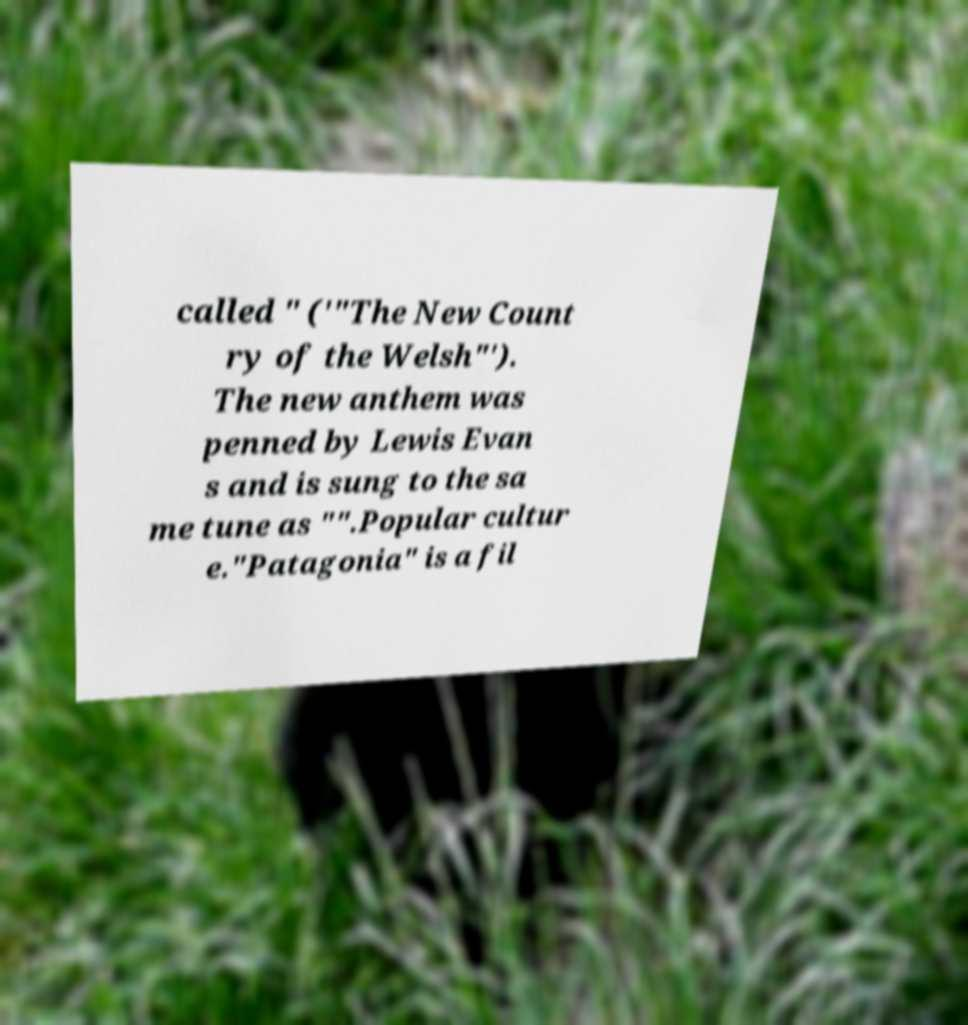Could you assist in decoding the text presented in this image and type it out clearly? called " ('"The New Count ry of the Welsh"'). The new anthem was penned by Lewis Evan s and is sung to the sa me tune as "".Popular cultur e."Patagonia" is a fil 